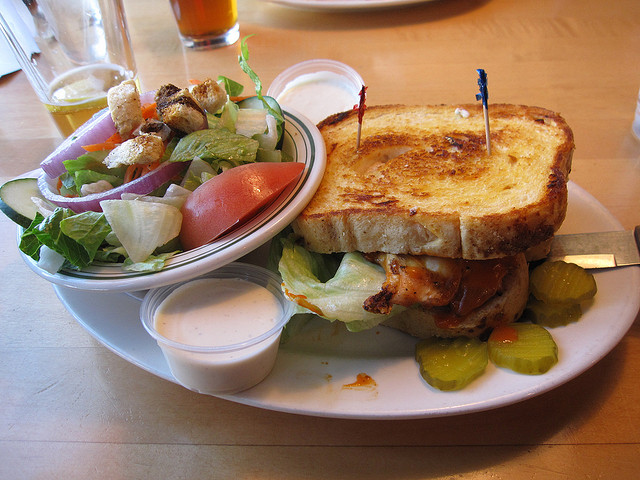What kind of bread is that? The bread in the image is thick and grilled, resembling a style commonly used for Texas toast, which is often served toasted with a crispy texture. 